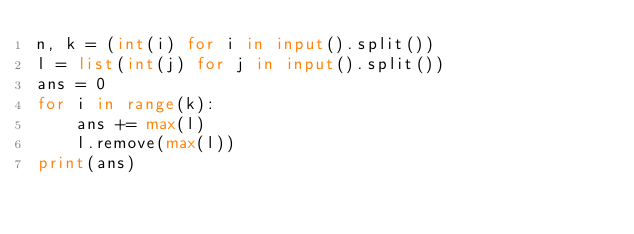Convert code to text. <code><loc_0><loc_0><loc_500><loc_500><_Python_>n, k = (int(i) for i in input().split())
l = list(int(j) for j in input().split())
ans = 0
for i in range(k):
    ans += max(l)
    l.remove(max(l))
print(ans)</code> 